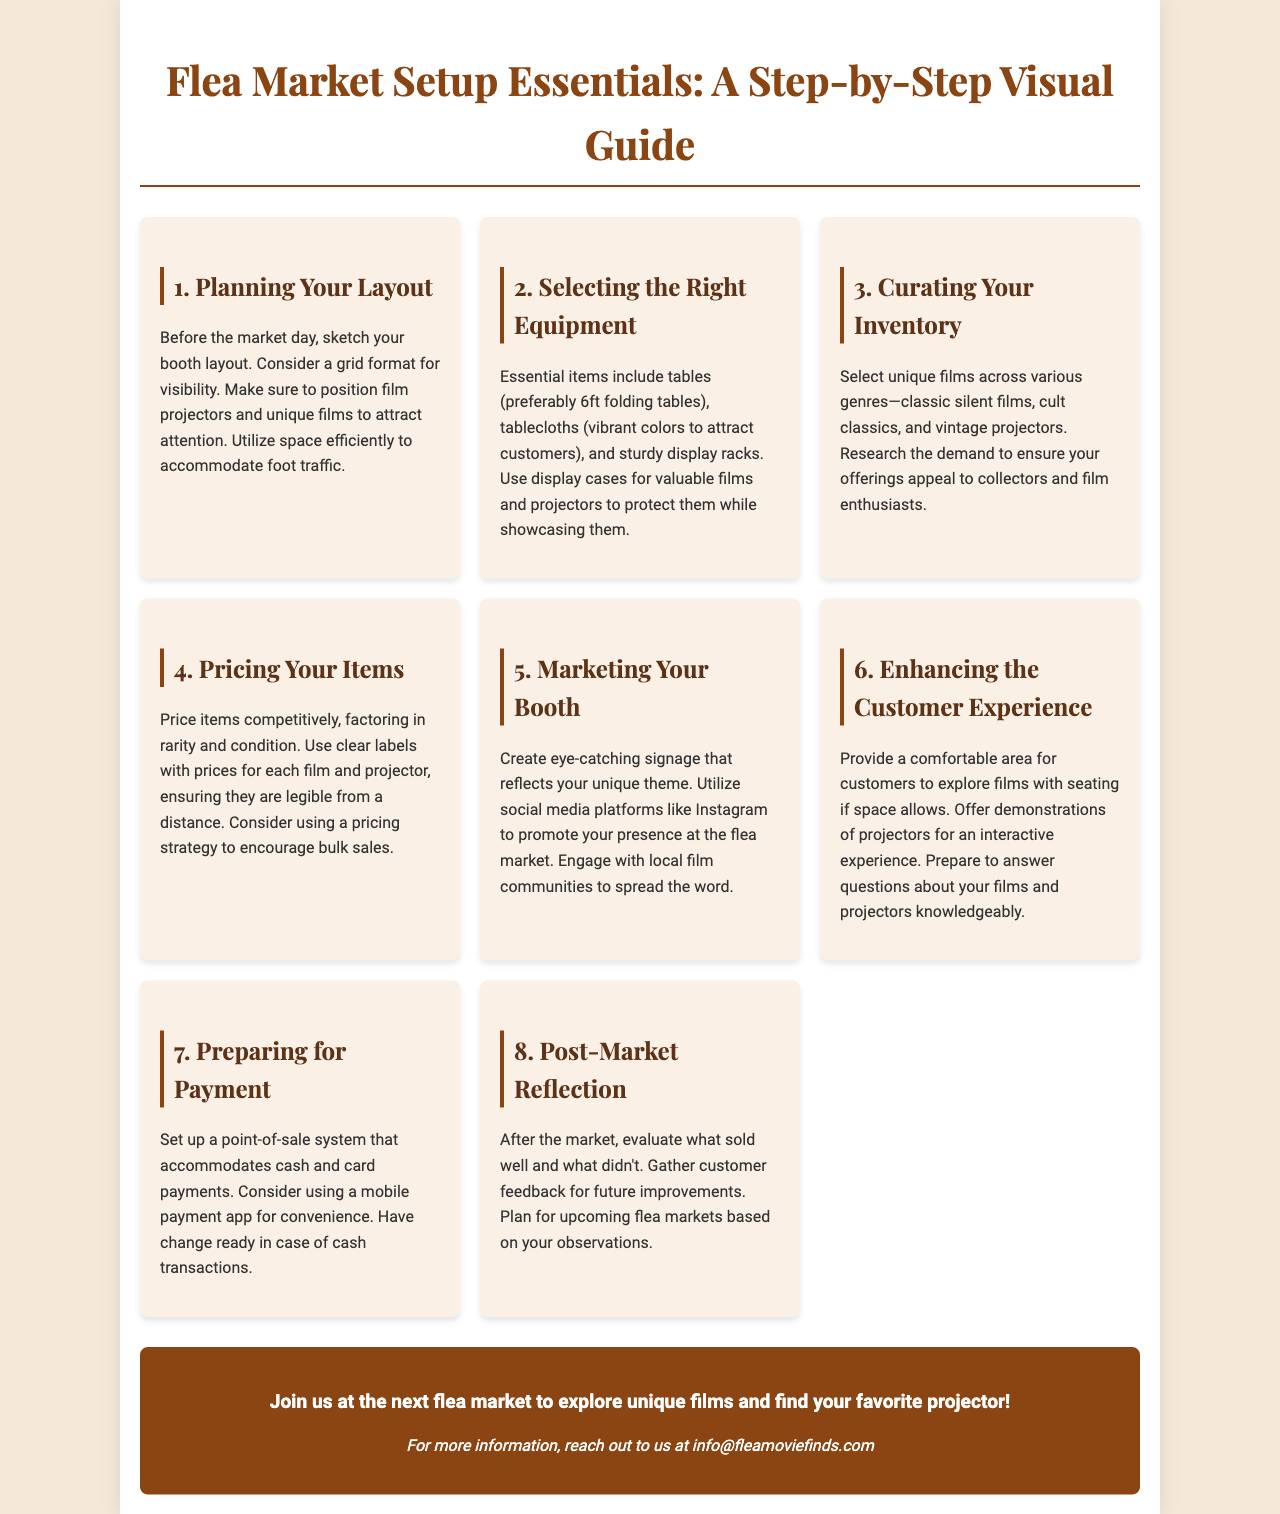What is the title of the guide? The title of the guide is mentioned at the beginning of the document.
Answer: Flea Market Setup Essentials: A Step-by-Step Visual Guide How many sections are there in the document? The document lists various sections, the count can be obtained by identifying each section header.
Answer: 8 What type of tables are suggested for use? The document specifies a preferred type of table for the setup.
Answer: 6ft folding tables What is a key item to use for displays? The document recommends a protective item for valuable films and projectors.
Answer: Display cases What should you do after the market? The document advises a specific action after the market concludes.
Answer: Evaluate what sold well Which social media platform is suggested for marketing? The document mentions a specific platform for promoting presence at the flea market.
Answer: Instagram What should be prepared for payment transactions? The document lists an essential element needed for transaction handling.
Answer: Change What is a unique type of film recommended for selection? The document provides examples of specific film types to curate.
Answer: Classic silent films 